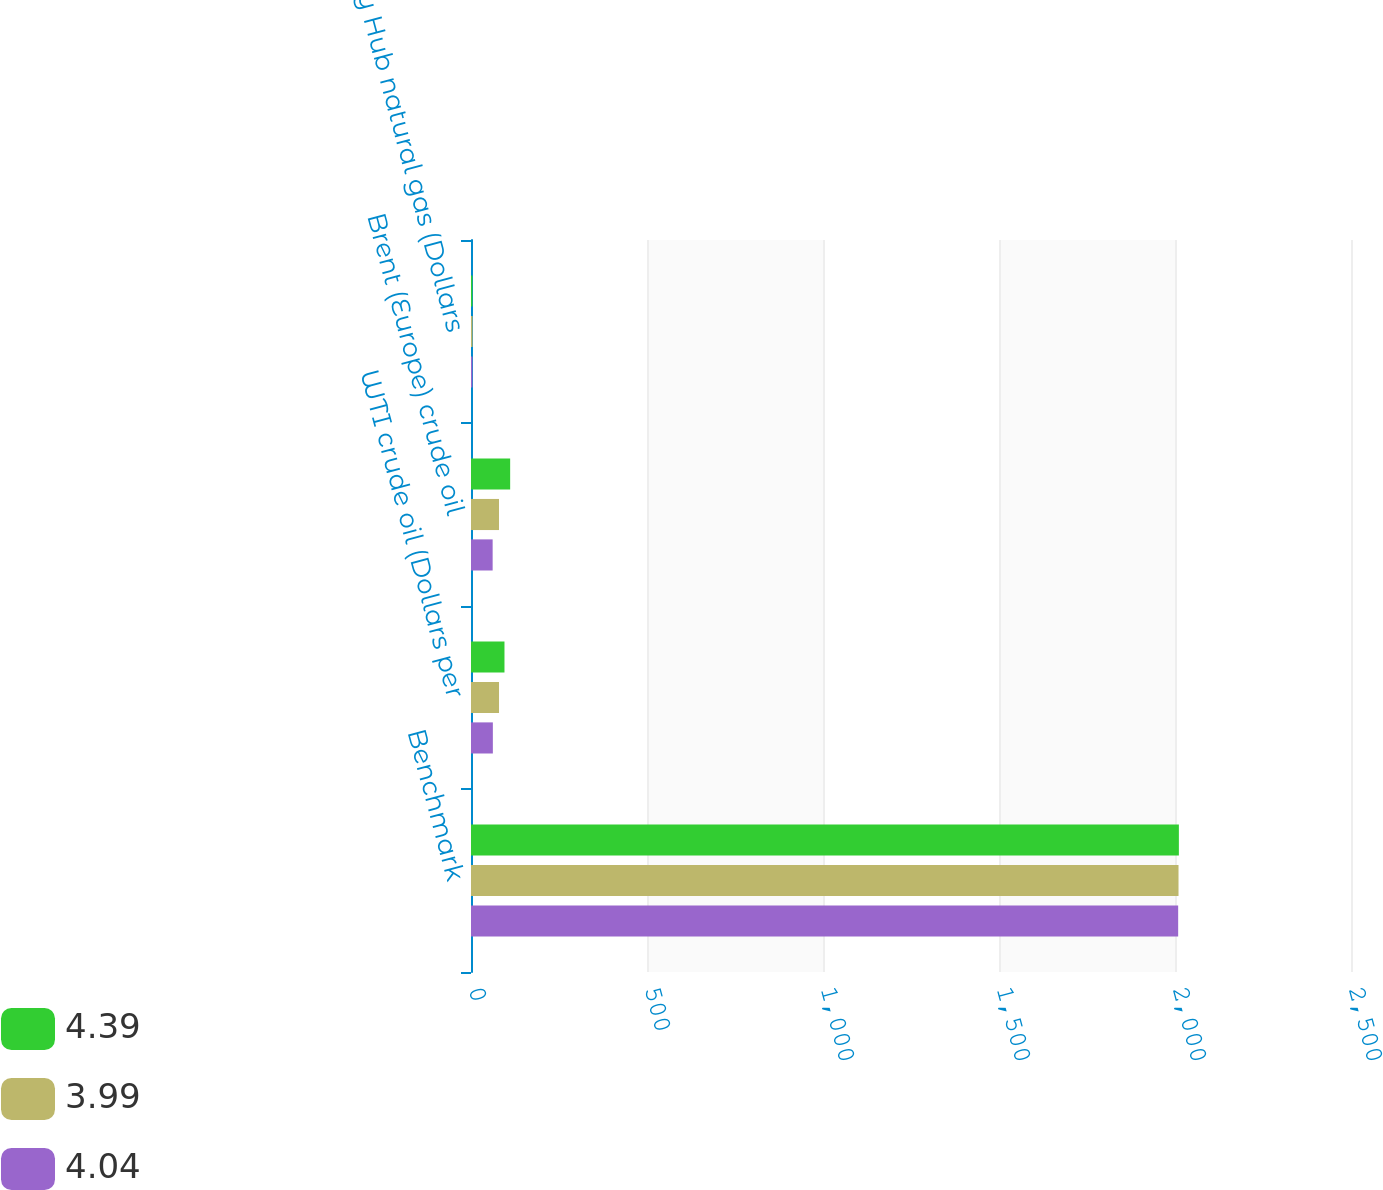Convert chart to OTSL. <chart><loc_0><loc_0><loc_500><loc_500><stacked_bar_chart><ecel><fcel>Benchmark<fcel>WTI crude oil (Dollars per<fcel>Brent (Europe) crude oil<fcel>Henry Hub natural gas (Dollars<nl><fcel>4.39<fcel>2011<fcel>95.11<fcel>111.26<fcel>4.04<nl><fcel>3.99<fcel>2010<fcel>79.61<fcel>79.51<fcel>4.39<nl><fcel>4.04<fcel>2009<fcel>62.09<fcel>61.49<fcel>3.99<nl></chart> 